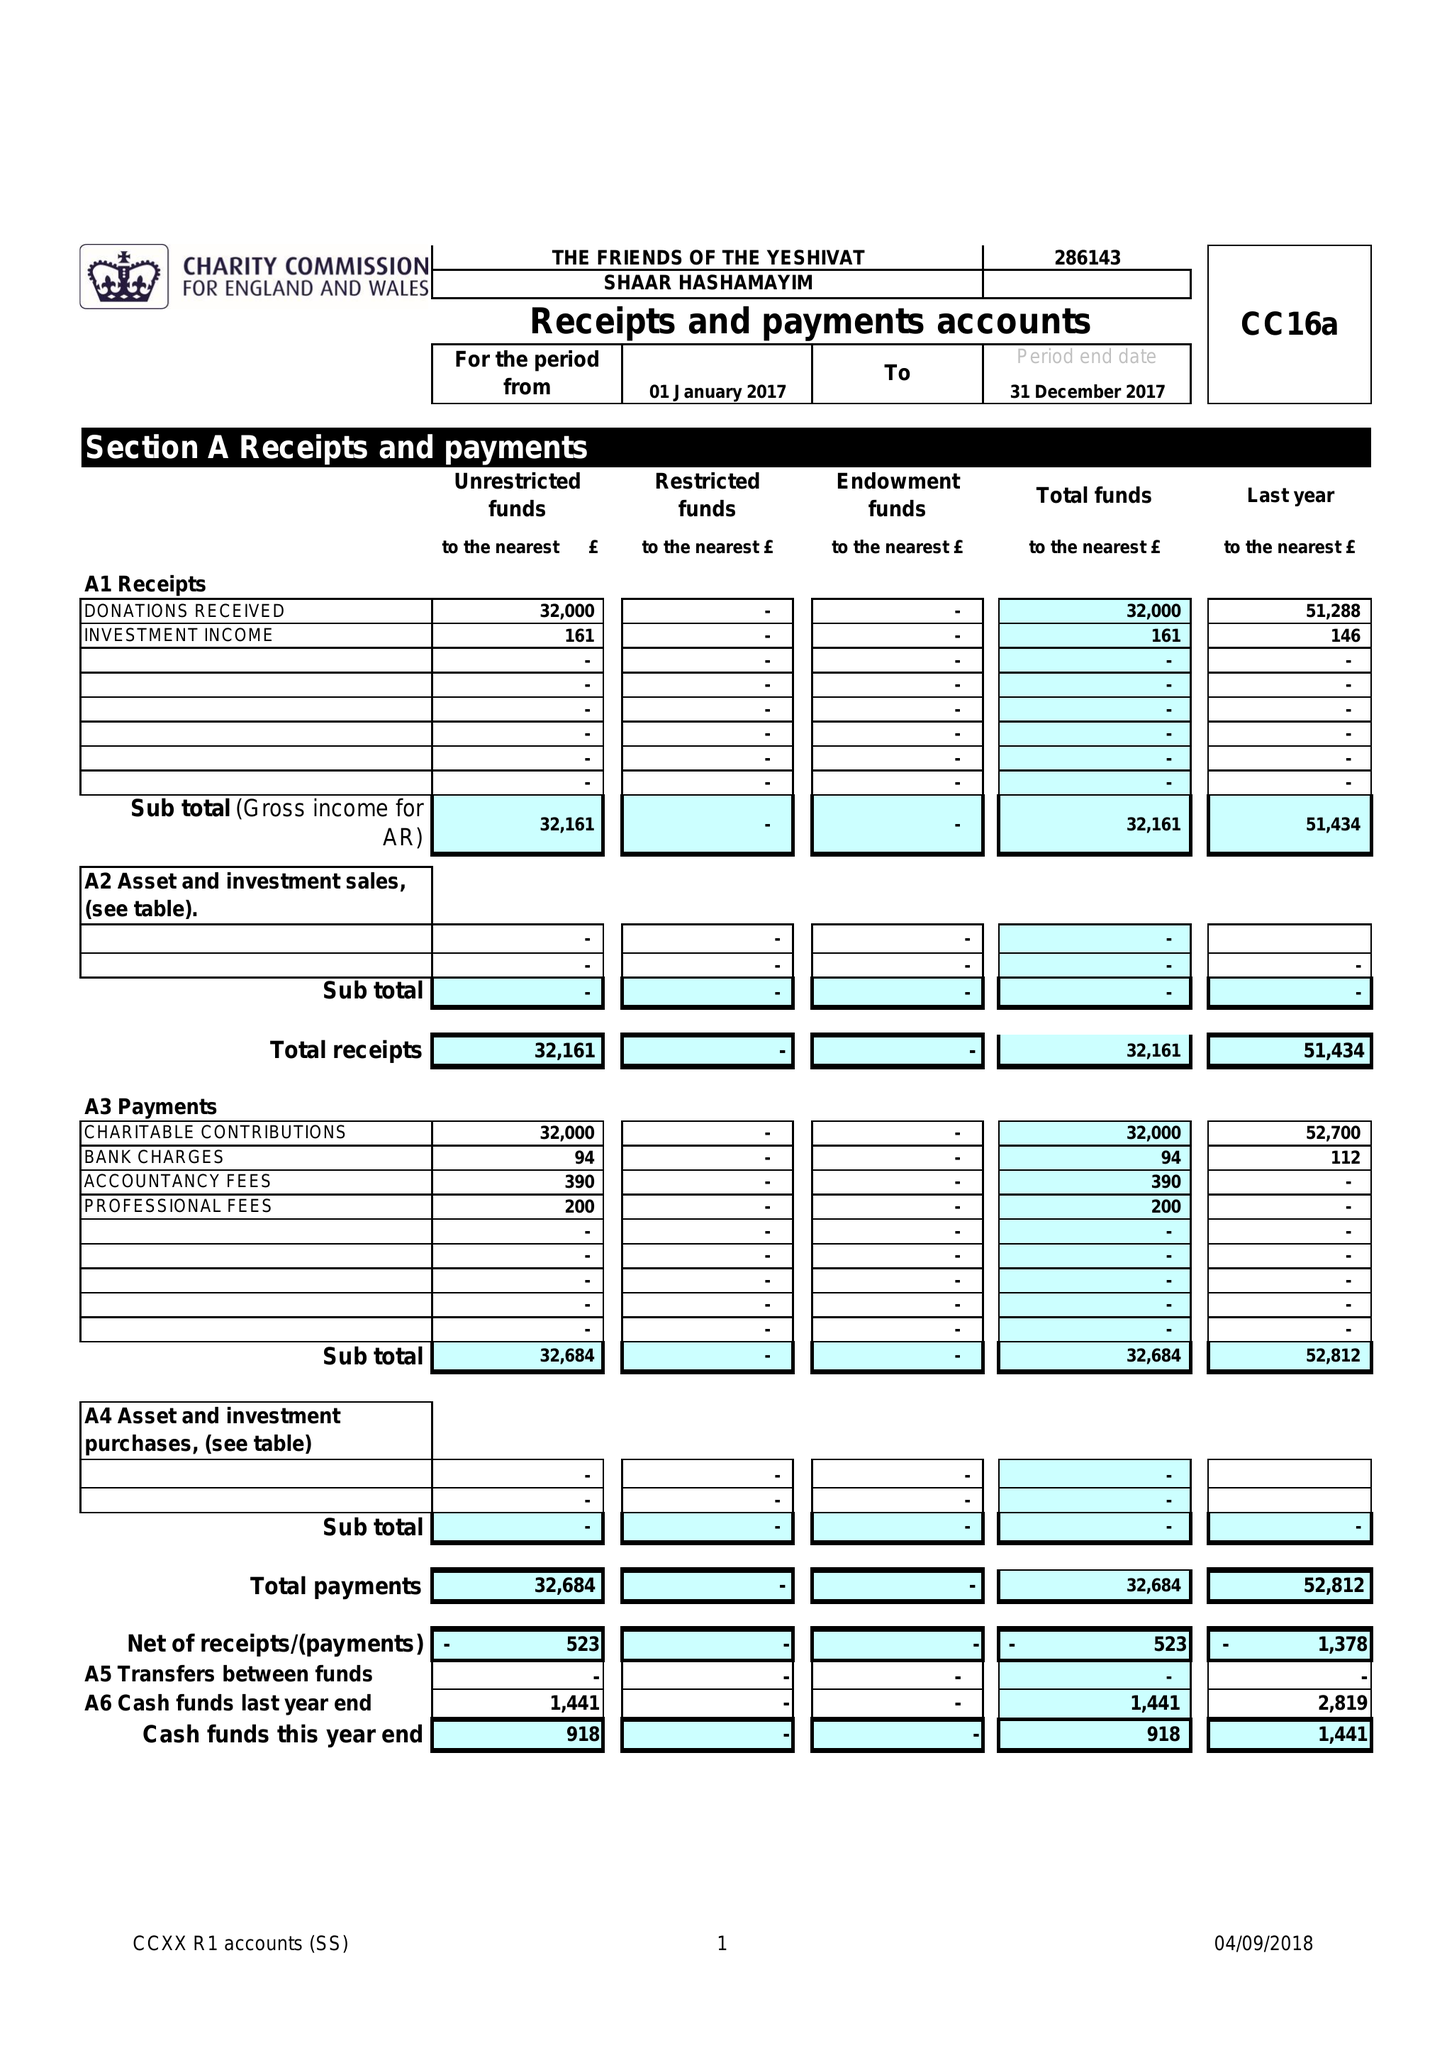What is the value for the report_date?
Answer the question using a single word or phrase. 2017-12-31 